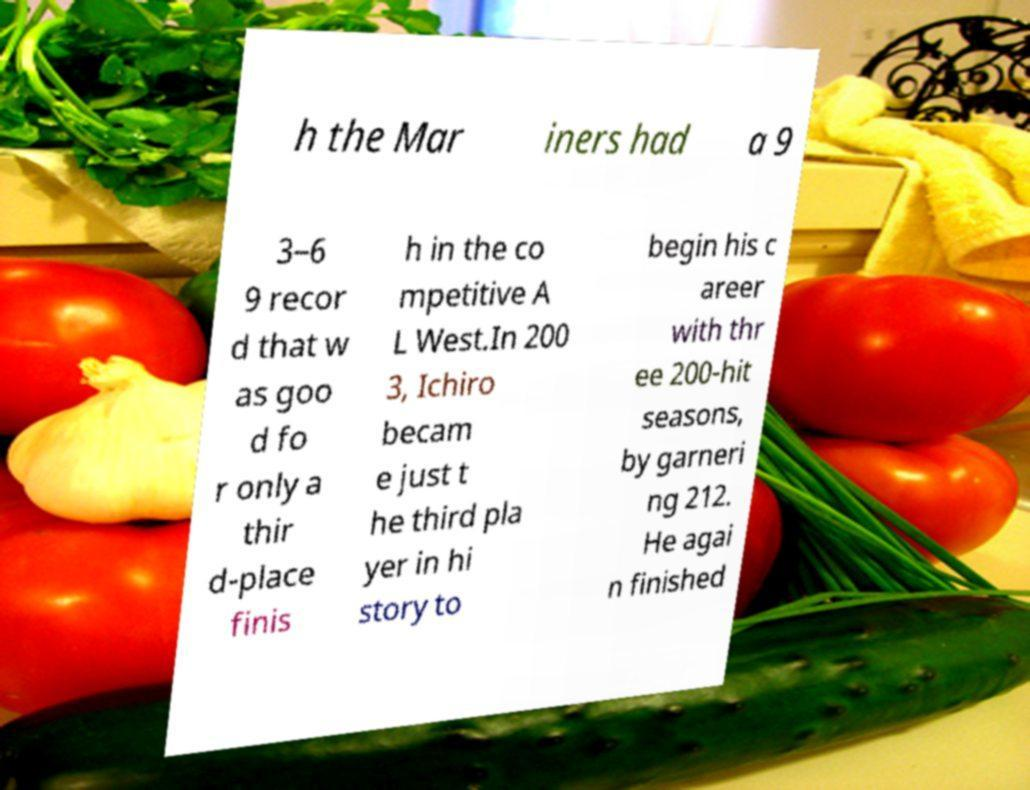Could you assist in decoding the text presented in this image and type it out clearly? h the Mar iners had a 9 3–6 9 recor d that w as goo d fo r only a thir d-place finis h in the co mpetitive A L West.In 200 3, Ichiro becam e just t he third pla yer in hi story to begin his c areer with thr ee 200-hit seasons, by garneri ng 212. He agai n finished 